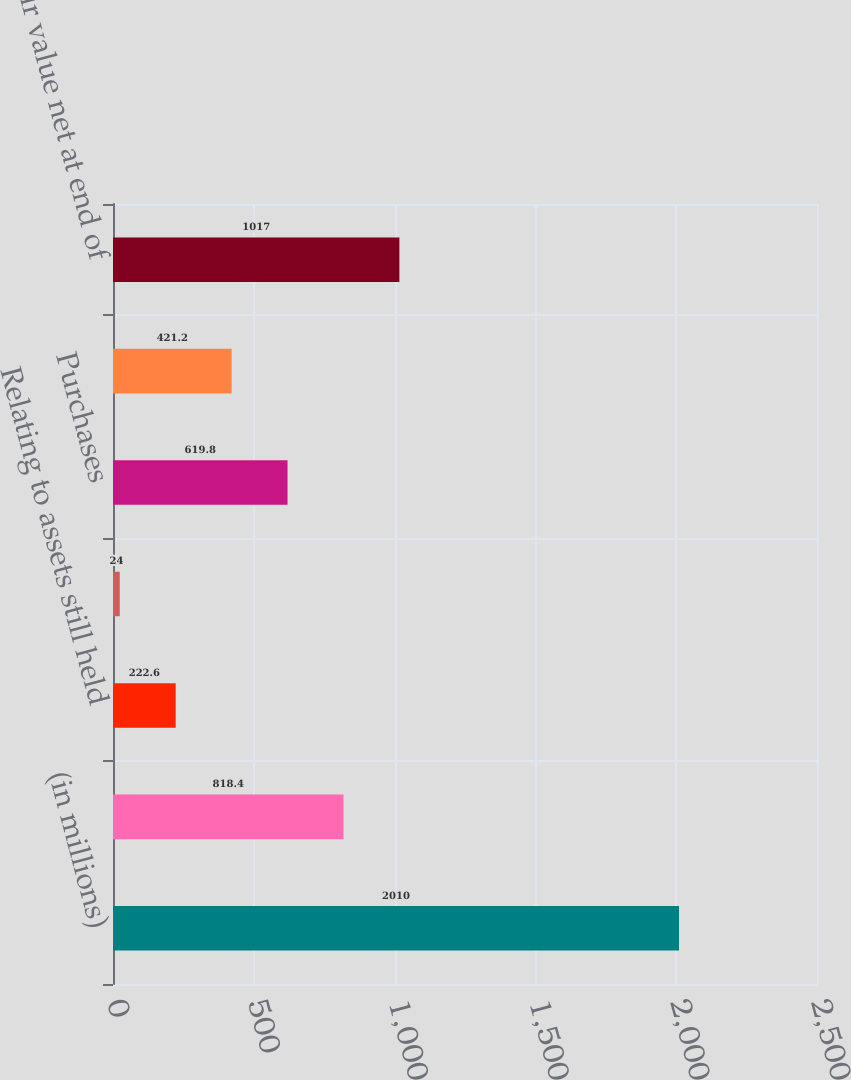<chart> <loc_0><loc_0><loc_500><loc_500><bar_chart><fcel>(in millions)<fcel>Fair value net at beginning of<fcel>Relating to assets still held<fcel>Relating to assets sold during<fcel>Purchases<fcel>Dispositions<fcel>Fair value net at end of<nl><fcel>2010<fcel>818.4<fcel>222.6<fcel>24<fcel>619.8<fcel>421.2<fcel>1017<nl></chart> 